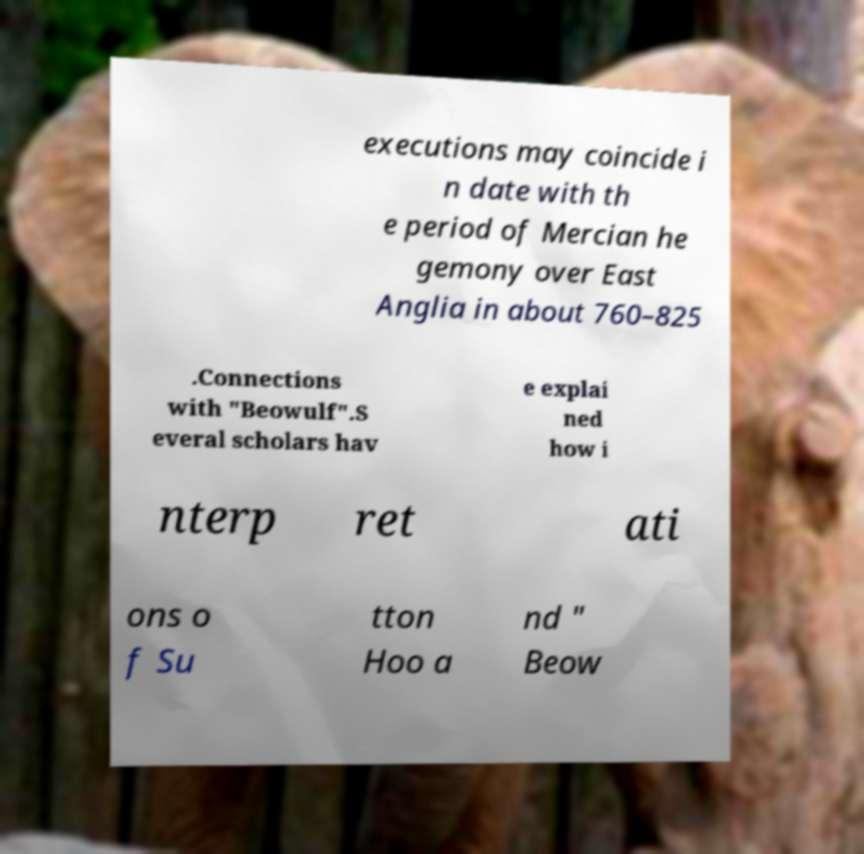Please identify and transcribe the text found in this image. executions may coincide i n date with th e period of Mercian he gemony over East Anglia in about 760–825 .Connections with "Beowulf".S everal scholars hav e explai ned how i nterp ret ati ons o f Su tton Hoo a nd " Beow 